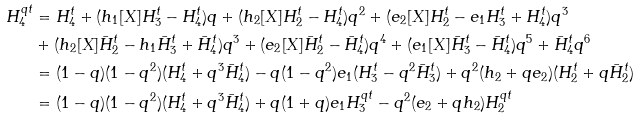<formula> <loc_0><loc_0><loc_500><loc_500>H _ { 4 } ^ { q t } & = H _ { 4 } ^ { t } + ( h _ { 1 } [ X ] H _ { 3 } ^ { t } - H _ { 4 } ^ { t } ) q + ( h _ { 2 } [ X ] H _ { 2 } ^ { t } - H _ { 4 } ^ { t } ) q ^ { 2 } + ( e _ { 2 } [ X ] H _ { 2 } ^ { t } - e _ { 1 } H _ { 3 } ^ { t } + H _ { 4 } ^ { t } ) q ^ { 3 } \\ & + ( h _ { 2 } [ X ] { \bar { H } } _ { 2 } ^ { t } - h _ { 1 } { \bar { H } } _ { 3 } ^ { t } + { \bar { H } } _ { 4 } ^ { t } ) q ^ { 3 } + ( e _ { 2 } [ X ] { \bar { H } } _ { 2 } ^ { t } - { \bar { H } } _ { 4 } ^ { t } ) q ^ { 4 } + ( e _ { 1 } [ X ] { \bar { H } } _ { 3 } ^ { t } - { \bar { H } } _ { 4 } ^ { t } ) q ^ { 5 } + { \bar { H } } _ { 4 } ^ { t } q ^ { 6 } \\ & = ( 1 - q ) ( 1 - q ^ { 2 } ) ( H _ { 4 } ^ { t } + q ^ { 3 } \bar { H } _ { 4 } ^ { t } ) - q ( 1 - q ^ { 2 } ) e _ { 1 } ( H _ { 3 } ^ { t } - q ^ { 2 } \bar { H } _ { 3 } ^ { t } ) + q ^ { 2 } ( h _ { 2 } + q e _ { 2 } ) ( H _ { 2 } ^ { t } + q { \bar { H } } _ { 2 } ^ { t } ) \\ & = ( 1 - q ) ( 1 - q ^ { 2 } ) ( H _ { 4 } ^ { t } + q ^ { 3 } \bar { H } _ { 4 } ^ { t } ) + q ( 1 + q ) e _ { 1 } H _ { 3 } ^ { q t } - q ^ { 2 } ( e _ { 2 } + q h _ { 2 } ) H _ { 2 } ^ { q t }</formula> 